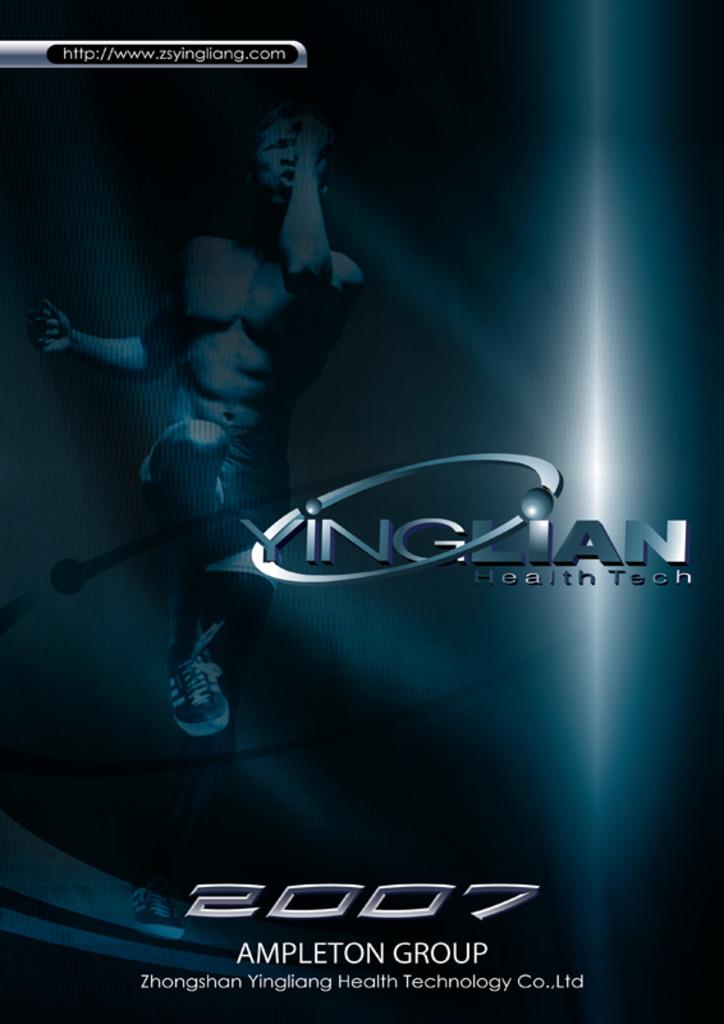What year is on the bottom?
Provide a succinct answer. 2007. What group is listed?
Offer a terse response. Ampleton. 